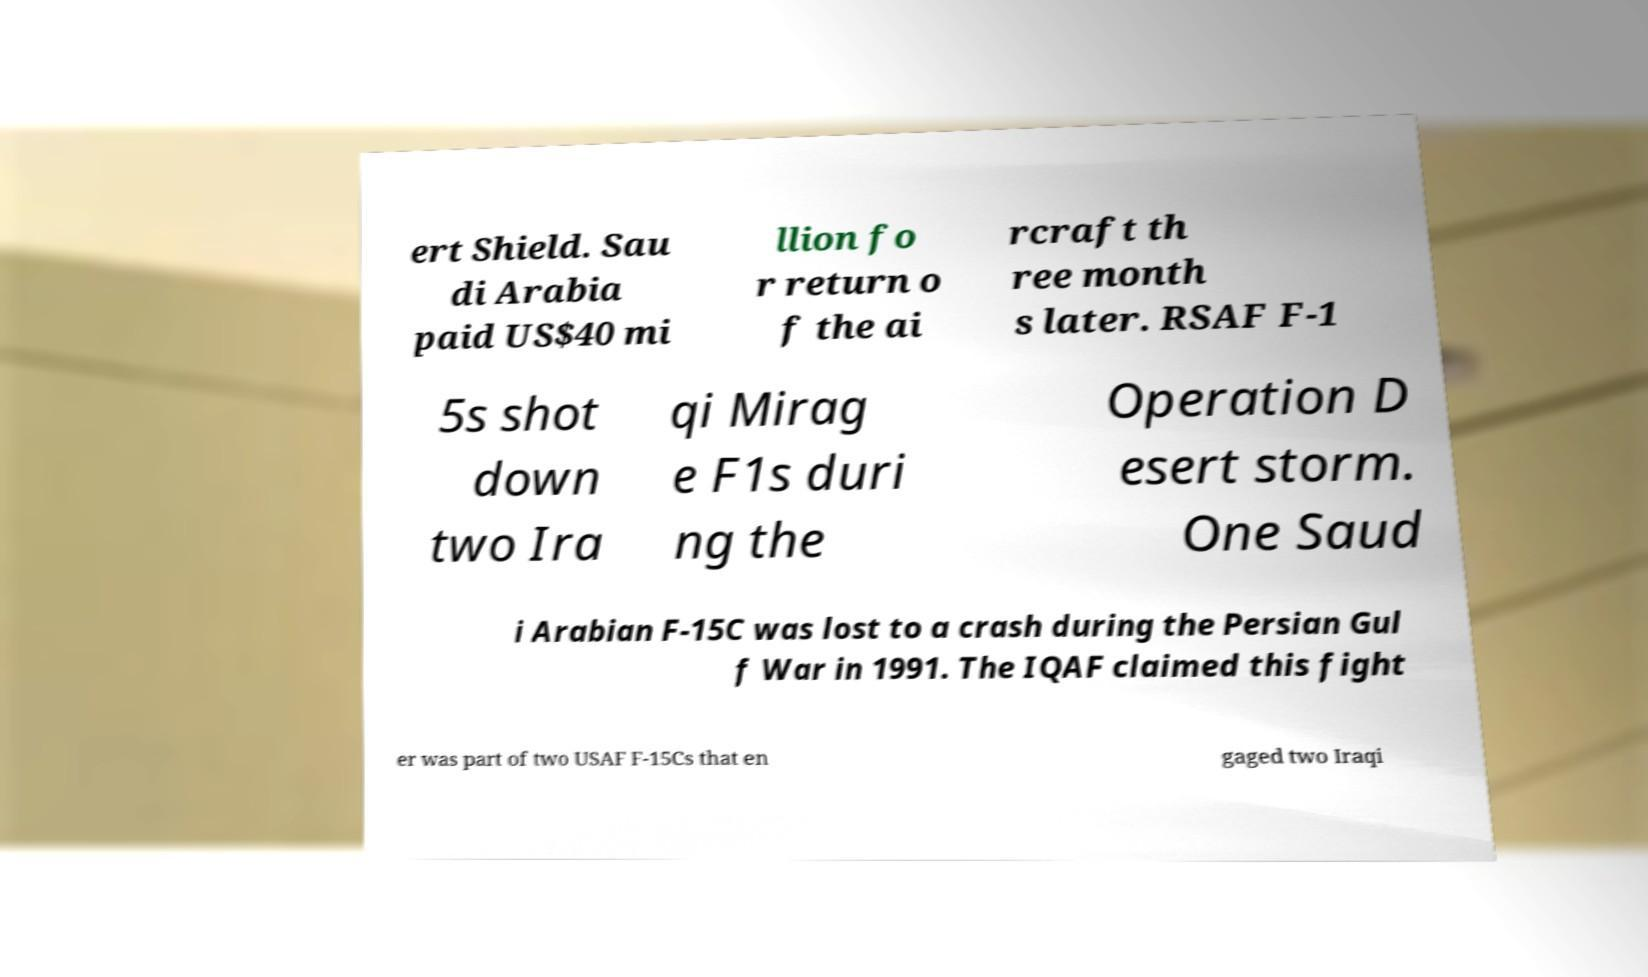What messages or text are displayed in this image? I need them in a readable, typed format. ert Shield. Sau di Arabia paid US$40 mi llion fo r return o f the ai rcraft th ree month s later. RSAF F-1 5s shot down two Ira qi Mirag e F1s duri ng the Operation D esert storm. One Saud i Arabian F-15C was lost to a crash during the Persian Gul f War in 1991. The IQAF claimed this fight er was part of two USAF F-15Cs that en gaged two Iraqi 